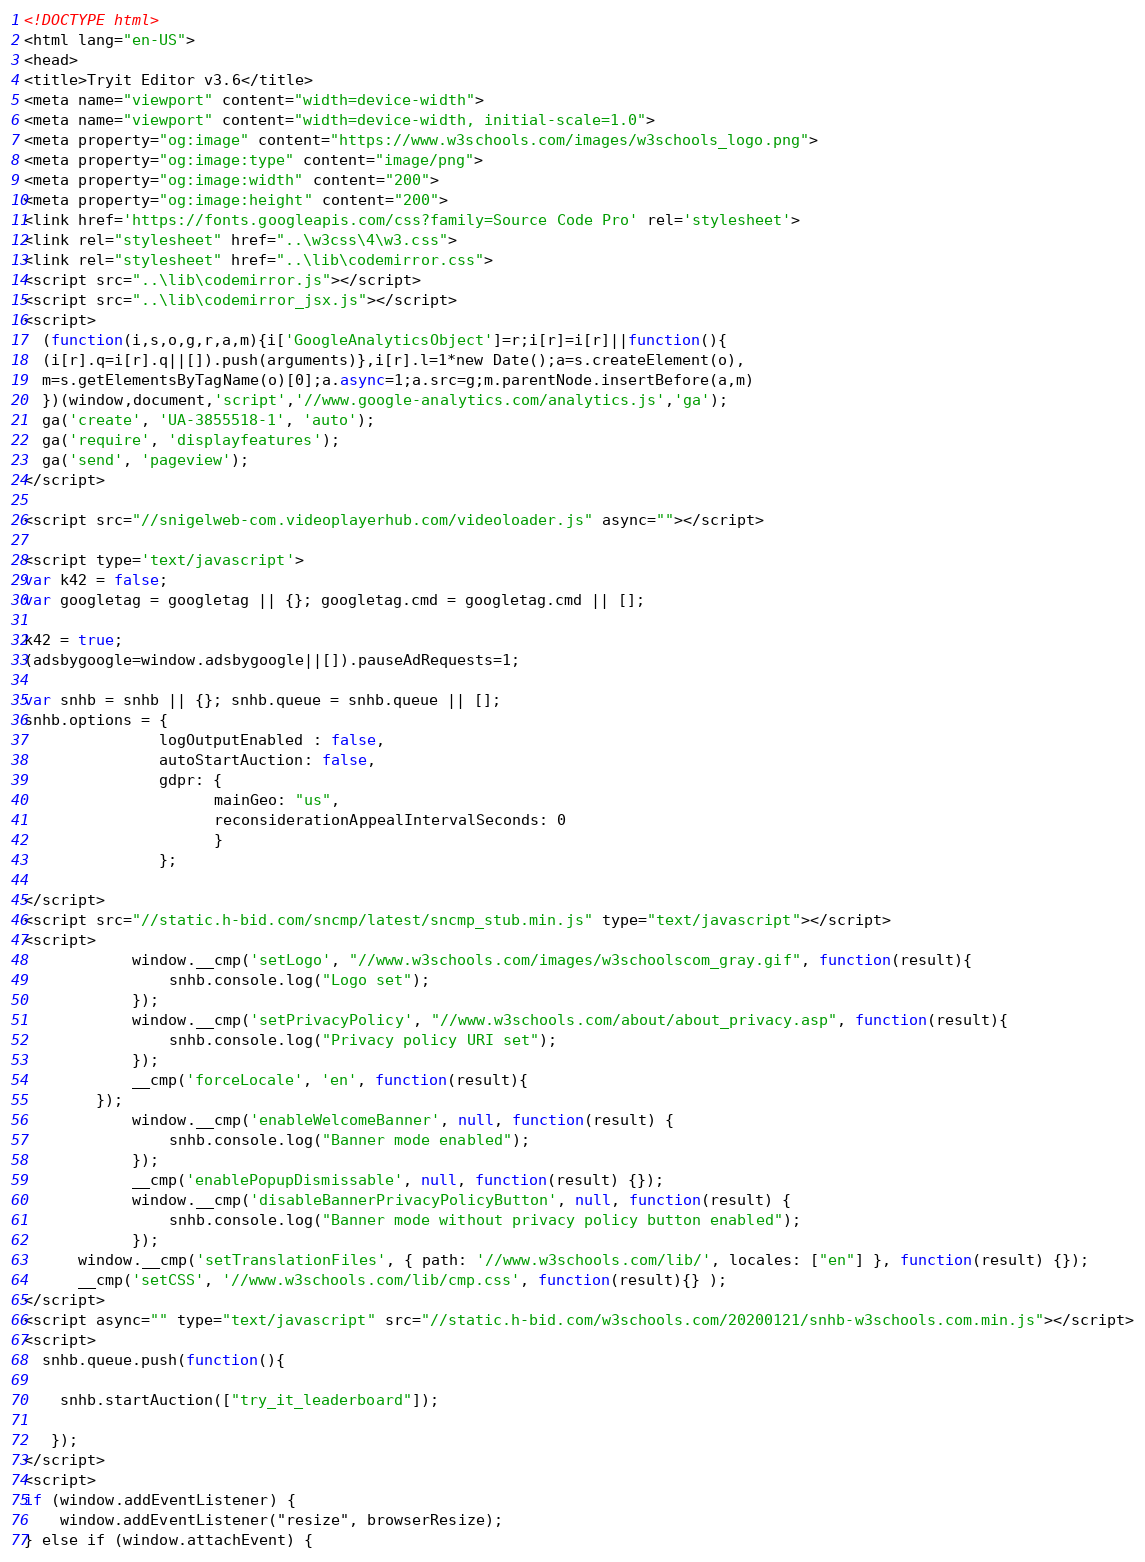Convert code to text. <code><loc_0><loc_0><loc_500><loc_500><_HTML_>
<!DOCTYPE html>
<html lang="en-US">
<head>
<title>Tryit Editor v3.6</title>
<meta name="viewport" content="width=device-width">
<meta name="viewport" content="width=device-width, initial-scale=1.0">
<meta property="og:image" content="https://www.w3schools.com/images/w3schools_logo.png">
<meta property="og:image:type" content="image/png">
<meta property="og:image:width" content="200">
<meta property="og:image:height" content="200">
<link href='https://fonts.googleapis.com/css?family=Source Code Pro' rel='stylesheet'>
<link rel="stylesheet" href="..\w3css\4\w3.css">
<link rel="stylesheet" href="..\lib\codemirror.css">
<script src="..\lib\codemirror.js"></script>
<script src="..\lib\codemirror_jsx.js"></script>
<script>
  (function(i,s,o,g,r,a,m){i['GoogleAnalyticsObject']=r;i[r]=i[r]||function(){
  (i[r].q=i[r].q||[]).push(arguments)},i[r].l=1*new Date();a=s.createElement(o),
  m=s.getElementsByTagName(o)[0];a.async=1;a.src=g;m.parentNode.insertBefore(a,m)
  })(window,document,'script','//www.google-analytics.com/analytics.js','ga');
  ga('create', 'UA-3855518-1', 'auto');
  ga('require', 'displayfeatures');
  ga('send', 'pageview');
</script>

<script src="//snigelweb-com.videoplayerhub.com/videoloader.js" async=""></script>

<script type='text/javascript'>
var k42 = false;
var googletag = googletag || {}; googletag.cmd = googletag.cmd || [];

k42 = true;
(adsbygoogle=window.adsbygoogle||[]).pauseAdRequests=1;

var snhb = snhb || {}; snhb.queue = snhb.queue || [];
snhb.options = {
               logOutputEnabled : false,
               autoStartAuction: false,
               gdpr: {
                     mainGeo: "us",
                     reconsiderationAppealIntervalSeconds: 0
                     }
               };

</script>
<script src="//static.h-bid.com/sncmp/latest/sncmp_stub.min.js" type="text/javascript"></script>
<script>
			window.__cmp('setLogo', "//www.w3schools.com/images/w3schoolscom_gray.gif", function(result){
	       		snhb.console.log("Logo set");
	    	});
			window.__cmp('setPrivacyPolicy', "//www.w3schools.com/about/about_privacy.asp", function(result){
	       		snhb.console.log("Privacy policy URI set");
	    	});
			__cmp('forceLocale', 'en', function(result){
	    });
			window.__cmp('enableWelcomeBanner', null, function(result) {
	       		snhb.console.log("Banner mode enabled");
			});
			__cmp('enablePopupDismissable', null, function(result) {});
			window.__cmp('disableBannerPrivacyPolicyButton', null, function(result) {
	       		snhb.console.log("Banner mode without privacy policy button enabled");
			});
      window.__cmp('setTranslationFiles', { path: '//www.w3schools.com/lib/', locales: ["en"] }, function(result) {});
      __cmp('setCSS', '//www.w3schools.com/lib/cmp.css', function(result){} );
</script>
<script async="" type="text/javascript" src="//static.h-bid.com/w3schools.com/20200121/snhb-w3schools.com.min.js"></script>
<script>
  snhb.queue.push(function(){

    snhb.startAuction(["try_it_leaderboard"]);

   });
</script>
<script>
if (window.addEventListener) {              
    window.addEventListener("resize", browserResize);
} else if (window.attachEvent) {                 </code> 